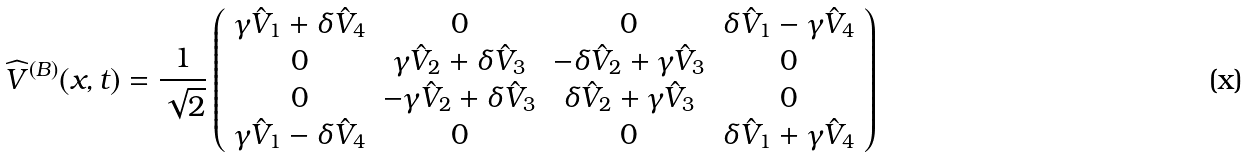<formula> <loc_0><loc_0><loc_500><loc_500>\widehat { V } ^ { ( B ) } ( x , t ) = \frac { 1 } { \sqrt { 2 } } \left ( \begin{array} { c c c c } \gamma \hat { V } _ { 1 } + \delta \hat { V } _ { 4 } & 0 & 0 & \delta \hat { V } _ { 1 } - \gamma \hat { V } _ { 4 } \\ 0 & \gamma \hat { V } _ { 2 } + \delta \hat { V } _ { 3 } & - \delta \hat { V } _ { 2 } + \gamma \hat { V } _ { 3 } & 0 \\ 0 & - \gamma \hat { V } _ { 2 } + \delta \hat { V } _ { 3 } & \delta \hat { V } _ { 2 } + \gamma \hat { V } _ { 3 } & 0 \\ \gamma \hat { V } _ { 1 } - \delta \hat { V } _ { 4 } & 0 & 0 & \delta \hat { V } _ { 1 } + \gamma \hat { V } _ { 4 } \end{array} \right )</formula> 